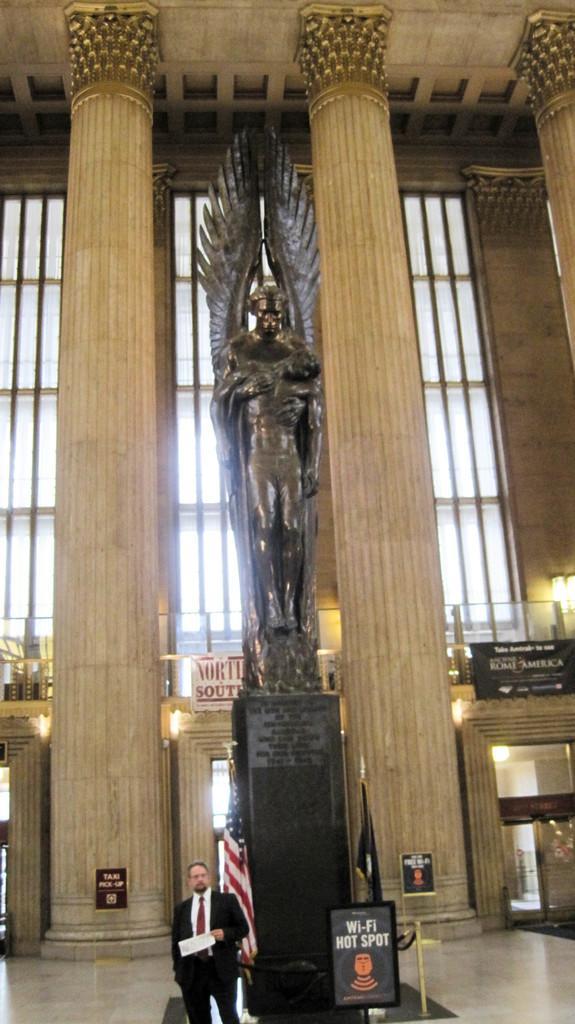In one or two sentences, can you explain what this image depicts? In the image there is a person standing in suit in front of statue with a flag behind him, in the background there are windows and pillars. 